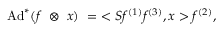<formula> <loc_0><loc_0><loc_500><loc_500>A d ^ { * } ( f \otimes x ) = < S f ^ { ( 1 ) } f ^ { ( 3 ) } , x > f ^ { ( 2 ) } ,</formula> 